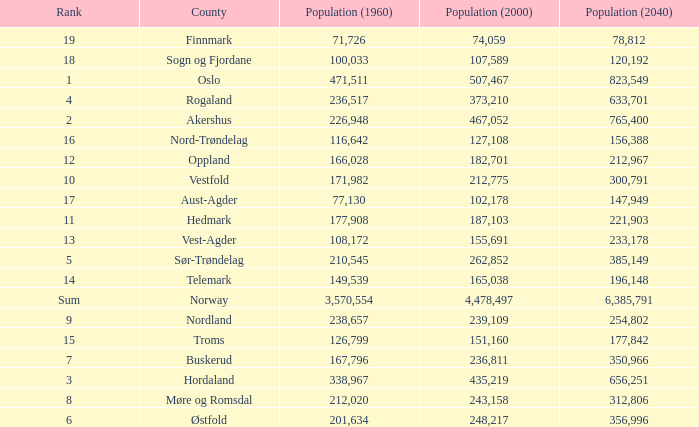What was the population of a county in 1960 that had a population of 467,052 in 2000 and 78,812 in 2040? None. 